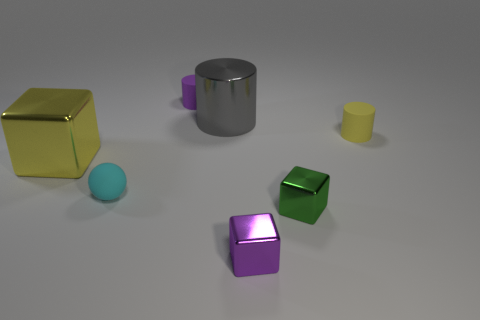Add 2 small yellow matte things. How many objects exist? 9 Subtract all cylinders. How many objects are left? 4 Subtract 0 yellow spheres. How many objects are left? 7 Subtract all small green cubes. Subtract all tiny blue objects. How many objects are left? 6 Add 7 rubber balls. How many rubber balls are left? 8 Add 4 matte cylinders. How many matte cylinders exist? 6 